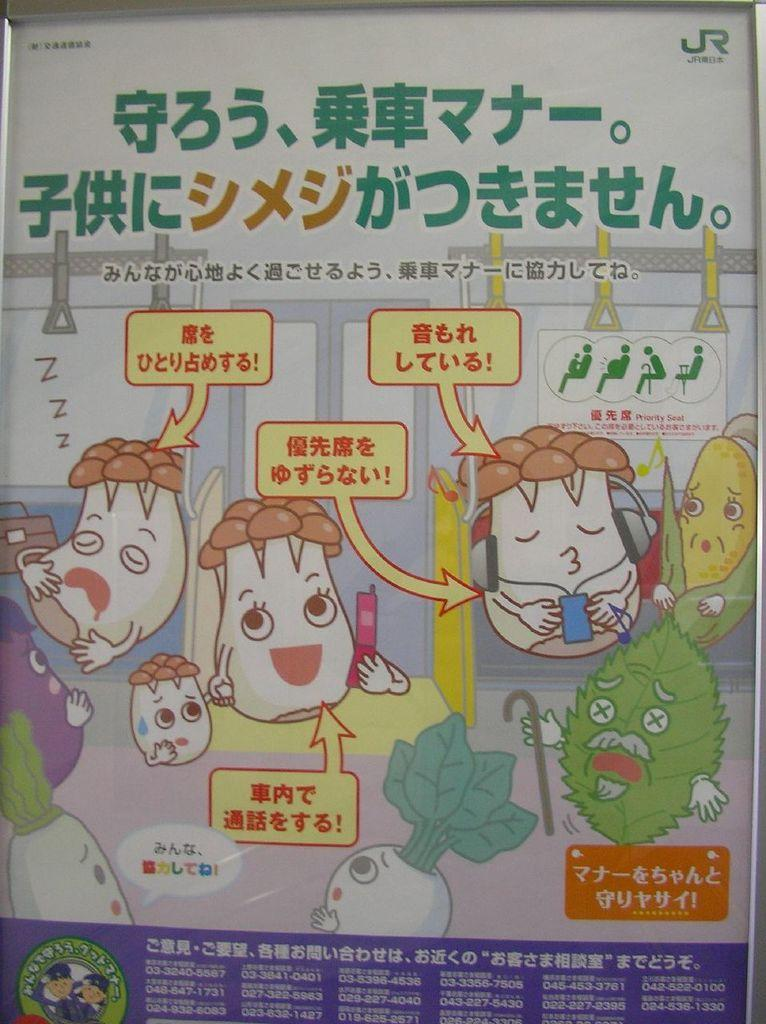What is featured in the image? There is a poster in the image. What type of images are on the poster? The poster contains animated pictures. Are there any words on the poster? Yes, there is text written on the poster. What type of treatment is being offered for the cat in the image? There is no cat present in the image, and therefore no treatment is being offered. 